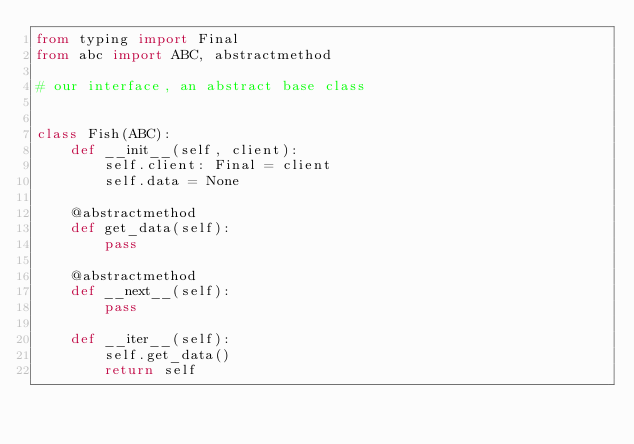<code> <loc_0><loc_0><loc_500><loc_500><_Python_>from typing import Final
from abc import ABC, abstractmethod

# our interface, an abstract base class


class Fish(ABC):
    def __init__(self, client):
        self.client: Final = client
        self.data = None

    @abstractmethod
    def get_data(self):
        pass

    @abstractmethod
    def __next__(self):
        pass

    def __iter__(self):
        self.get_data()
        return self
</code> 